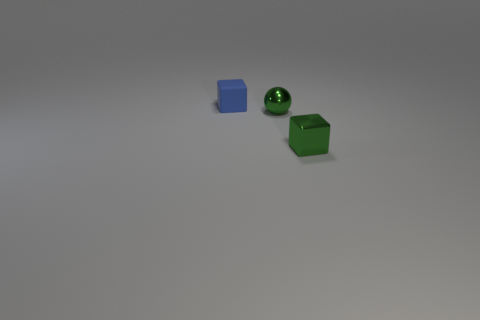What material is the other small green object that is the same shape as the small matte object?
Give a very brief answer. Metal. The tiny green metal object that is in front of the small green thing that is behind the tiny block in front of the blue rubber thing is what shape?
Provide a short and direct response. Cube. Is the number of tiny spheres that are in front of the tiny blue matte block greater than the number of big green metallic cylinders?
Provide a succinct answer. Yes. Do the tiny green metallic object right of the green metal sphere and the blue thing have the same shape?
Provide a succinct answer. Yes. There is a cube that is behind the sphere; what is its material?
Keep it short and to the point. Rubber. What number of green shiny objects are the same shape as the blue object?
Offer a terse response. 1. The small cube that is to the right of the tiny matte thing on the left side of the tiny green metallic block is made of what material?
Offer a very short reply. Metal. There is a metal object that is the same color as the small sphere; what is its shape?
Your answer should be very brief. Cube. Is there a tiny green thing made of the same material as the green cube?
Offer a terse response. Yes. How many small green cubes are there?
Offer a terse response. 1. 